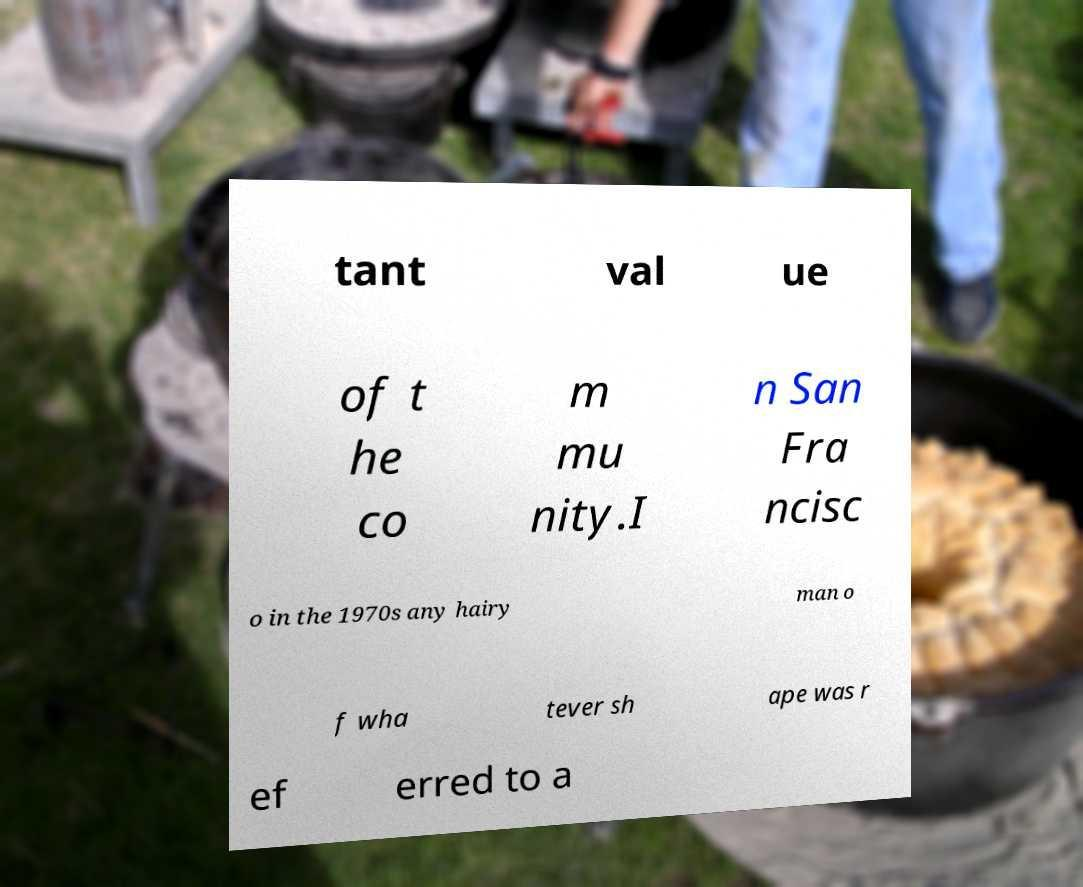I need the written content from this picture converted into text. Can you do that? tant val ue of t he co m mu nity.I n San Fra ncisc o in the 1970s any hairy man o f wha tever sh ape was r ef erred to a 